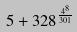<formula> <loc_0><loc_0><loc_500><loc_500>5 + 3 2 8 ^ { \frac { 4 ^ { 8 } } { 3 0 1 } }</formula> 